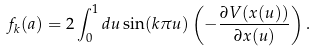Convert formula to latex. <formula><loc_0><loc_0><loc_500><loc_500>f _ { k } ( a ) = 2 \int _ { 0 } ^ { 1 } d u \sin ( k \pi u ) \left ( - \frac { \partial V ( x ( u ) ) } { \partial x ( u ) } \right ) .</formula> 